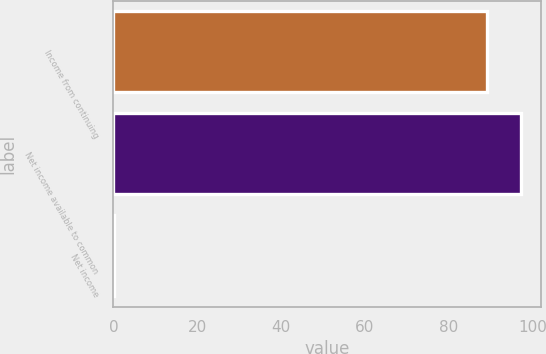Convert chart. <chart><loc_0><loc_0><loc_500><loc_500><bar_chart><fcel>Income from continuing<fcel>Net income available to common<fcel>Net income<nl><fcel>89.09<fcel>97.19<fcel>0.05<nl></chart> 